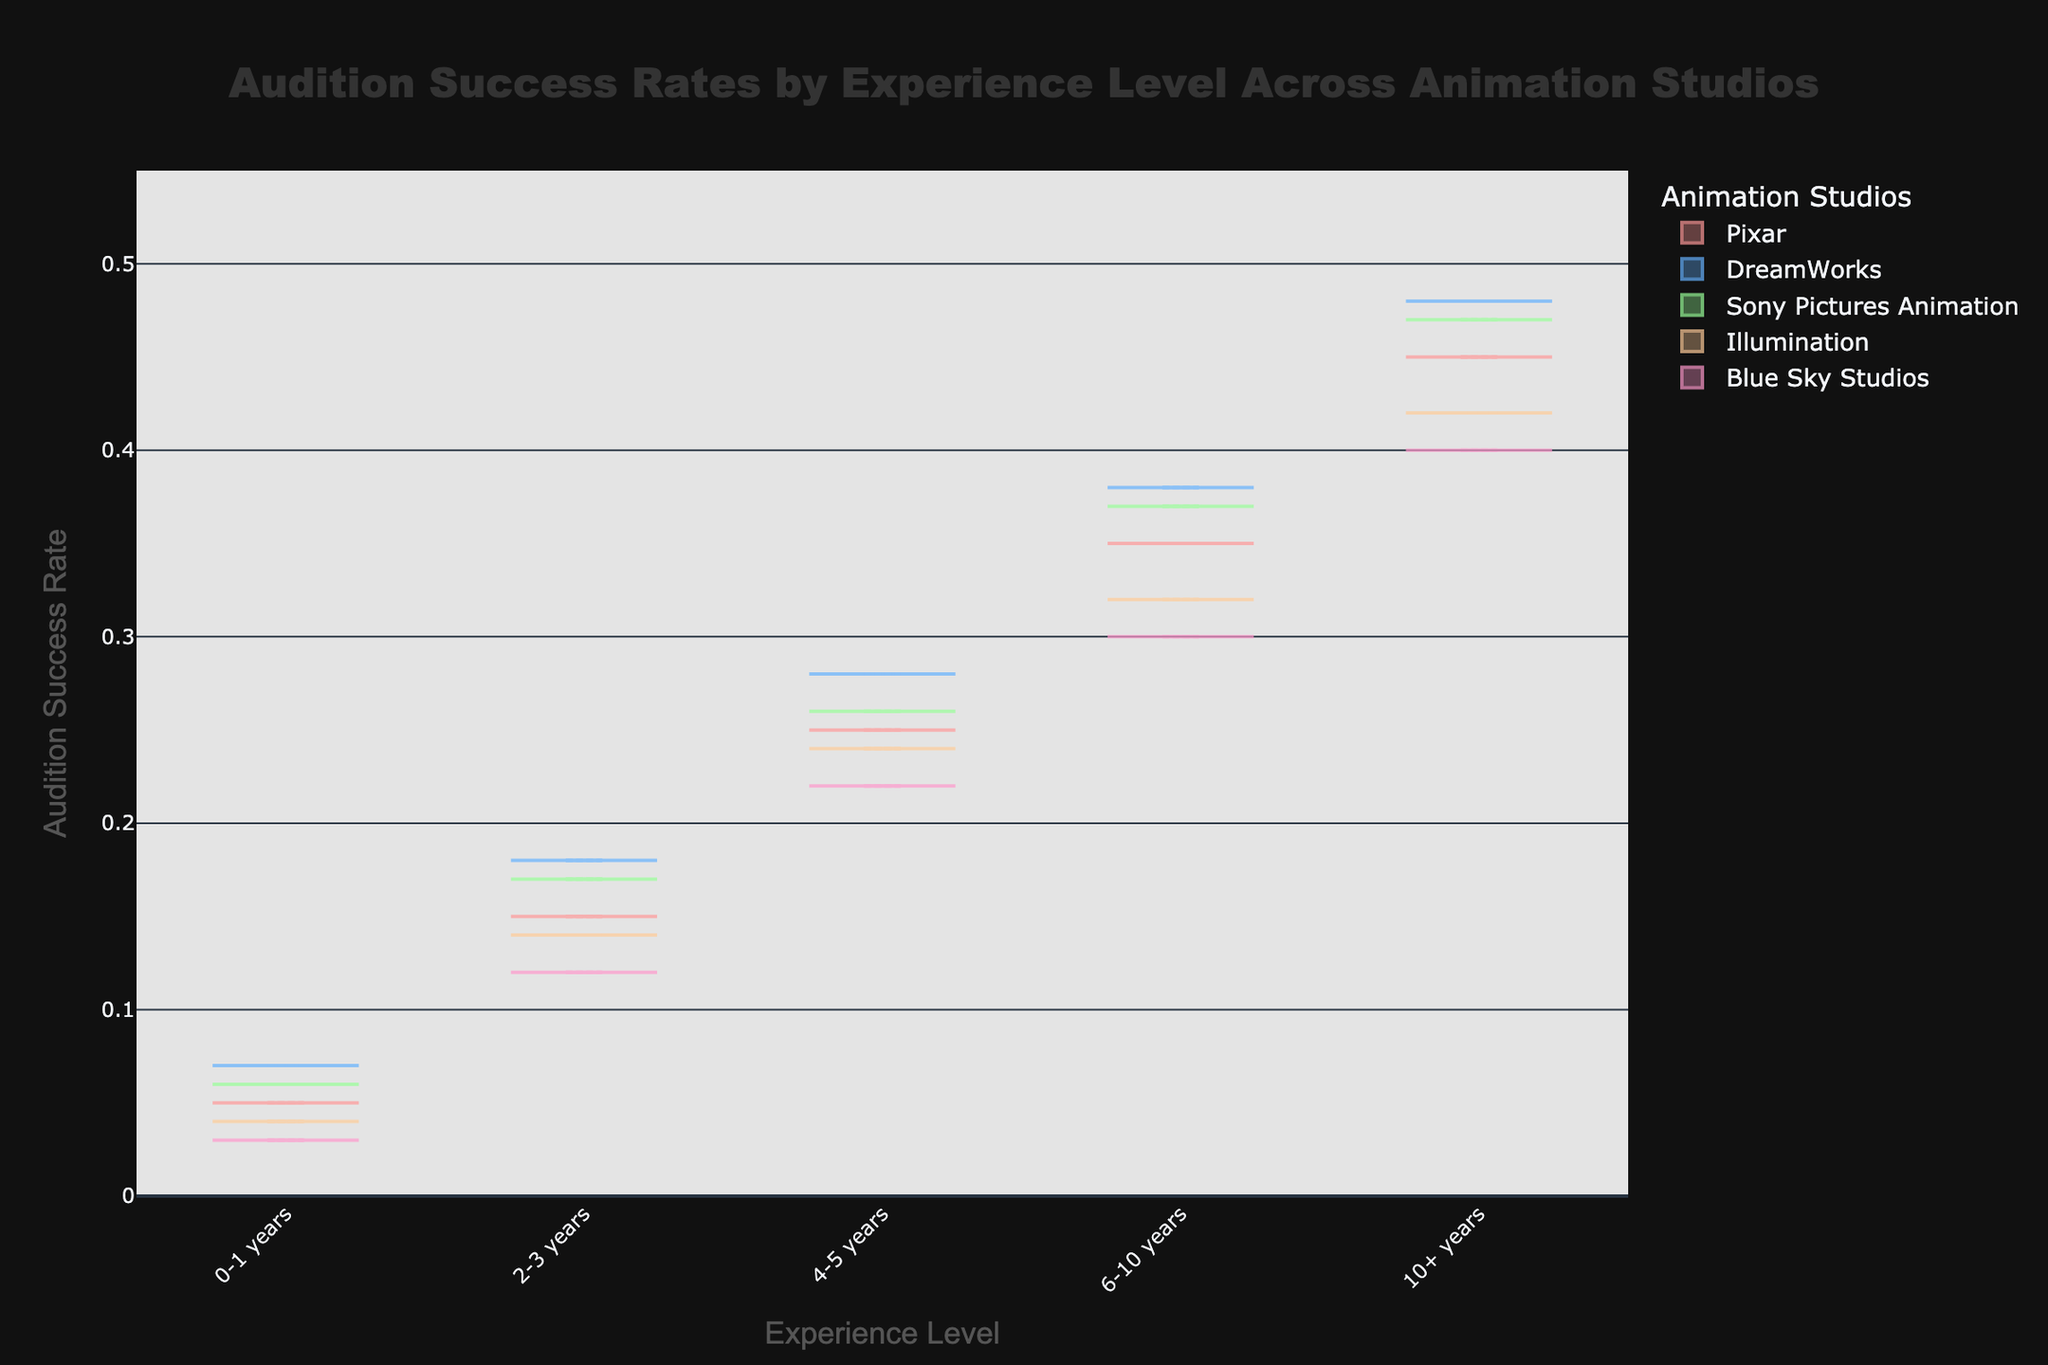What are the experience levels represented in the chart? The experience levels are shown on the x-axis in the figure. They include labels for different ranges of experience.
Answer: 0-1 years, 2-3 years, 4-5 years, 6-10 years, 10+ years Which studio has the lowest audition success rate for the 0-1 years experience level? On the violin plot, we review the points at the 0-1 years experience level and identify the lowest point among the studios.
Answer: Blue Sky Studios At which experience level does Pixar have a higher audition success rate compared to Illumination? By analyzing each experience level category, compare the audition success rates of Pixar and Illumination to find at least one instance where Pixar's rate is higher.
Answer: 4-5 years, 6-10 years, 10+ years What is the general trend of audition success rates as experience level increases across all studios? By observing the overall distribution patterns of the violin plots for each studio, note how audition success rates change with increasing experience levels.
Answer: Increases How does DreamWorks' audition success rate for the 10+ years experience level compare to Pixar's for the same level? Identify the points representing the 10+ years experience level for both DreamWorks and Pixar. Compare the values to see which is higher.
Answer: DreamWorks is higher Across all studios, which experience level shows the most variability in audition success rates? Assess the width and shape of the violin plots for each experience level across all studios to identify which experience level plot varies the most.
Answer: 0-1 years Comparing all studios, which one has the highest audition success rate for the 6-10 years experience level? Look at the 6-10 years experience level points for each studio and compare them to find the highest rate.
Answer: DreamWorks How do the success rates for Blue Sky Studios and Illumination compare at the 2-3 years experience level? By examining the points representing the 2-3 years experience level for both studios, compare their respective audition success rates.
Answer: Illumination is higher 